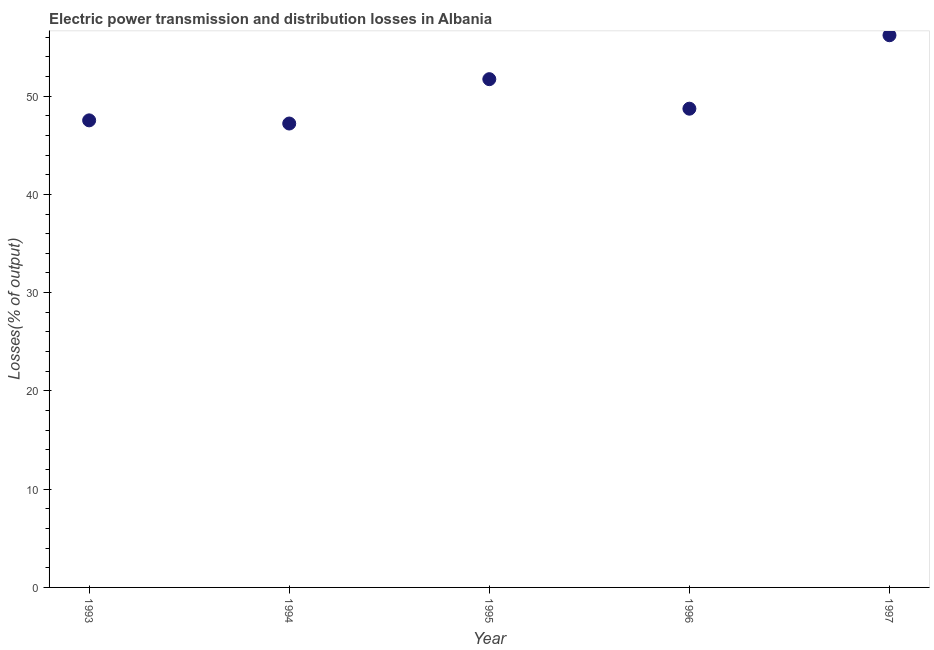What is the electric power transmission and distribution losses in 1994?
Offer a terse response. 47.21. Across all years, what is the maximum electric power transmission and distribution losses?
Give a very brief answer. 56.19. Across all years, what is the minimum electric power transmission and distribution losses?
Your response must be concise. 47.21. In which year was the electric power transmission and distribution losses maximum?
Provide a short and direct response. 1997. What is the sum of the electric power transmission and distribution losses?
Keep it short and to the point. 251.37. What is the difference between the electric power transmission and distribution losses in 1993 and 1994?
Give a very brief answer. 0.32. What is the average electric power transmission and distribution losses per year?
Provide a succinct answer. 50.27. What is the median electric power transmission and distribution losses?
Your response must be concise. 48.72. What is the ratio of the electric power transmission and distribution losses in 1994 to that in 1996?
Give a very brief answer. 0.97. Is the difference between the electric power transmission and distribution losses in 1993 and 1994 greater than the difference between any two years?
Your answer should be compact. No. What is the difference between the highest and the second highest electric power transmission and distribution losses?
Offer a terse response. 4.47. What is the difference between the highest and the lowest electric power transmission and distribution losses?
Offer a very short reply. 8.98. In how many years, is the electric power transmission and distribution losses greater than the average electric power transmission and distribution losses taken over all years?
Your response must be concise. 2. How many dotlines are there?
Provide a short and direct response. 1. Does the graph contain grids?
Keep it short and to the point. No. What is the title of the graph?
Give a very brief answer. Electric power transmission and distribution losses in Albania. What is the label or title of the X-axis?
Give a very brief answer. Year. What is the label or title of the Y-axis?
Provide a short and direct response. Losses(% of output). What is the Losses(% of output) in 1993?
Provide a short and direct response. 47.53. What is the Losses(% of output) in 1994?
Ensure brevity in your answer.  47.21. What is the Losses(% of output) in 1995?
Provide a succinct answer. 51.72. What is the Losses(% of output) in 1996?
Your answer should be very brief. 48.72. What is the Losses(% of output) in 1997?
Your answer should be very brief. 56.19. What is the difference between the Losses(% of output) in 1993 and 1994?
Ensure brevity in your answer.  0.32. What is the difference between the Losses(% of output) in 1993 and 1995?
Provide a succinct answer. -4.19. What is the difference between the Losses(% of output) in 1993 and 1996?
Keep it short and to the point. -1.19. What is the difference between the Losses(% of output) in 1993 and 1997?
Offer a terse response. -8.66. What is the difference between the Losses(% of output) in 1994 and 1995?
Offer a terse response. -4.51. What is the difference between the Losses(% of output) in 1994 and 1996?
Your response must be concise. -1.51. What is the difference between the Losses(% of output) in 1994 and 1997?
Offer a very short reply. -8.98. What is the difference between the Losses(% of output) in 1995 and 1996?
Make the answer very short. 3. What is the difference between the Losses(% of output) in 1995 and 1997?
Ensure brevity in your answer.  -4.47. What is the difference between the Losses(% of output) in 1996 and 1997?
Provide a short and direct response. -7.47. What is the ratio of the Losses(% of output) in 1993 to that in 1995?
Keep it short and to the point. 0.92. What is the ratio of the Losses(% of output) in 1993 to that in 1997?
Offer a terse response. 0.85. What is the ratio of the Losses(% of output) in 1994 to that in 1997?
Give a very brief answer. 0.84. What is the ratio of the Losses(% of output) in 1995 to that in 1996?
Offer a terse response. 1.06. What is the ratio of the Losses(% of output) in 1996 to that in 1997?
Keep it short and to the point. 0.87. 